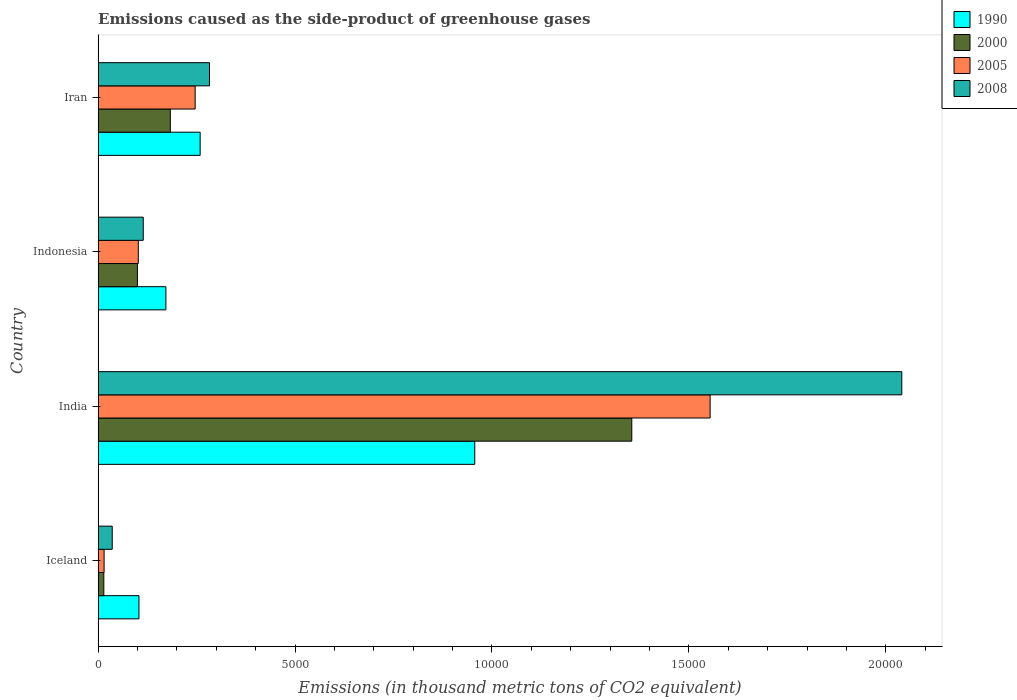How many different coloured bars are there?
Offer a terse response. 4. How many groups of bars are there?
Your answer should be compact. 4. Are the number of bars per tick equal to the number of legend labels?
Ensure brevity in your answer.  Yes. Are the number of bars on each tick of the Y-axis equal?
Provide a short and direct response. Yes. What is the label of the 4th group of bars from the top?
Your response must be concise. Iceland. What is the emissions caused as the side-product of greenhouse gases in 2008 in Iran?
Offer a very short reply. 2828.5. Across all countries, what is the maximum emissions caused as the side-product of greenhouse gases in 2008?
Your answer should be very brief. 2.04e+04. Across all countries, what is the minimum emissions caused as the side-product of greenhouse gases in 2008?
Provide a succinct answer. 358.5. In which country was the emissions caused as the side-product of greenhouse gases in 2005 maximum?
Make the answer very short. India. In which country was the emissions caused as the side-product of greenhouse gases in 2005 minimum?
Ensure brevity in your answer.  Iceland. What is the total emissions caused as the side-product of greenhouse gases in 2008 in the graph?
Give a very brief answer. 2.47e+04. What is the difference between the emissions caused as the side-product of greenhouse gases in 2000 in India and that in Indonesia?
Keep it short and to the point. 1.26e+04. What is the difference between the emissions caused as the side-product of greenhouse gases in 2005 in Iceland and the emissions caused as the side-product of greenhouse gases in 2000 in Iran?
Keep it short and to the point. -1681.7. What is the average emissions caused as the side-product of greenhouse gases in 2005 per country?
Your answer should be very brief. 4793.98. What is the difference between the emissions caused as the side-product of greenhouse gases in 2000 and emissions caused as the side-product of greenhouse gases in 2008 in Iceland?
Offer a terse response. -213.7. What is the ratio of the emissions caused as the side-product of greenhouse gases in 2008 in India to that in Indonesia?
Your answer should be very brief. 17.81. Is the emissions caused as the side-product of greenhouse gases in 2000 in Iceland less than that in India?
Provide a succinct answer. Yes. What is the difference between the highest and the second highest emissions caused as the side-product of greenhouse gases in 2000?
Ensure brevity in your answer.  1.17e+04. What is the difference between the highest and the lowest emissions caused as the side-product of greenhouse gases in 2005?
Make the answer very short. 1.54e+04. Is the sum of the emissions caused as the side-product of greenhouse gases in 1990 in Iceland and Iran greater than the maximum emissions caused as the side-product of greenhouse gases in 2008 across all countries?
Your response must be concise. No. What does the 1st bar from the top in Iran represents?
Offer a very short reply. 2008. What does the 2nd bar from the bottom in Iran represents?
Give a very brief answer. 2000. Are all the bars in the graph horizontal?
Offer a terse response. Yes. How many countries are there in the graph?
Your response must be concise. 4. What is the difference between two consecutive major ticks on the X-axis?
Provide a succinct answer. 5000. Are the values on the major ticks of X-axis written in scientific E-notation?
Give a very brief answer. No. How many legend labels are there?
Provide a short and direct response. 4. What is the title of the graph?
Your response must be concise. Emissions caused as the side-product of greenhouse gases. Does "2006" appear as one of the legend labels in the graph?
Offer a terse response. No. What is the label or title of the X-axis?
Give a very brief answer. Emissions (in thousand metric tons of CO2 equivalent). What is the label or title of the Y-axis?
Ensure brevity in your answer.  Country. What is the Emissions (in thousand metric tons of CO2 equivalent) of 1990 in Iceland?
Ensure brevity in your answer.  1036.9. What is the Emissions (in thousand metric tons of CO2 equivalent) in 2000 in Iceland?
Your answer should be very brief. 144.8. What is the Emissions (in thousand metric tons of CO2 equivalent) of 2005 in Iceland?
Give a very brief answer. 151.7. What is the Emissions (in thousand metric tons of CO2 equivalent) of 2008 in Iceland?
Offer a terse response. 358.5. What is the Emissions (in thousand metric tons of CO2 equivalent) in 1990 in India?
Ensure brevity in your answer.  9563.6. What is the Emissions (in thousand metric tons of CO2 equivalent) of 2000 in India?
Offer a very short reply. 1.36e+04. What is the Emissions (in thousand metric tons of CO2 equivalent) of 2005 in India?
Your answer should be compact. 1.55e+04. What is the Emissions (in thousand metric tons of CO2 equivalent) in 2008 in India?
Provide a succinct answer. 2.04e+04. What is the Emissions (in thousand metric tons of CO2 equivalent) in 1990 in Indonesia?
Ensure brevity in your answer.  1720.7. What is the Emissions (in thousand metric tons of CO2 equivalent) of 2000 in Indonesia?
Ensure brevity in your answer.  997.4. What is the Emissions (in thousand metric tons of CO2 equivalent) in 2005 in Indonesia?
Give a very brief answer. 1020.5. What is the Emissions (in thousand metric tons of CO2 equivalent) in 2008 in Indonesia?
Your answer should be very brief. 1146. What is the Emissions (in thousand metric tons of CO2 equivalent) in 1990 in Iran?
Ensure brevity in your answer.  2590.8. What is the Emissions (in thousand metric tons of CO2 equivalent) of 2000 in Iran?
Provide a succinct answer. 1833.4. What is the Emissions (in thousand metric tons of CO2 equivalent) of 2005 in Iran?
Offer a terse response. 2464. What is the Emissions (in thousand metric tons of CO2 equivalent) of 2008 in Iran?
Offer a terse response. 2828.5. Across all countries, what is the maximum Emissions (in thousand metric tons of CO2 equivalent) of 1990?
Make the answer very short. 9563.6. Across all countries, what is the maximum Emissions (in thousand metric tons of CO2 equivalent) in 2000?
Your response must be concise. 1.36e+04. Across all countries, what is the maximum Emissions (in thousand metric tons of CO2 equivalent) in 2005?
Keep it short and to the point. 1.55e+04. Across all countries, what is the maximum Emissions (in thousand metric tons of CO2 equivalent) in 2008?
Offer a very short reply. 2.04e+04. Across all countries, what is the minimum Emissions (in thousand metric tons of CO2 equivalent) in 1990?
Your answer should be very brief. 1036.9. Across all countries, what is the minimum Emissions (in thousand metric tons of CO2 equivalent) in 2000?
Give a very brief answer. 144.8. Across all countries, what is the minimum Emissions (in thousand metric tons of CO2 equivalent) of 2005?
Your response must be concise. 151.7. Across all countries, what is the minimum Emissions (in thousand metric tons of CO2 equivalent) of 2008?
Offer a terse response. 358.5. What is the total Emissions (in thousand metric tons of CO2 equivalent) of 1990 in the graph?
Your answer should be very brief. 1.49e+04. What is the total Emissions (in thousand metric tons of CO2 equivalent) in 2000 in the graph?
Give a very brief answer. 1.65e+04. What is the total Emissions (in thousand metric tons of CO2 equivalent) in 2005 in the graph?
Give a very brief answer. 1.92e+04. What is the total Emissions (in thousand metric tons of CO2 equivalent) in 2008 in the graph?
Your answer should be very brief. 2.47e+04. What is the difference between the Emissions (in thousand metric tons of CO2 equivalent) of 1990 in Iceland and that in India?
Give a very brief answer. -8526.7. What is the difference between the Emissions (in thousand metric tons of CO2 equivalent) of 2000 in Iceland and that in India?
Your response must be concise. -1.34e+04. What is the difference between the Emissions (in thousand metric tons of CO2 equivalent) of 2005 in Iceland and that in India?
Ensure brevity in your answer.  -1.54e+04. What is the difference between the Emissions (in thousand metric tons of CO2 equivalent) of 2008 in Iceland and that in India?
Provide a succinct answer. -2.00e+04. What is the difference between the Emissions (in thousand metric tons of CO2 equivalent) of 1990 in Iceland and that in Indonesia?
Keep it short and to the point. -683.8. What is the difference between the Emissions (in thousand metric tons of CO2 equivalent) of 2000 in Iceland and that in Indonesia?
Your answer should be compact. -852.6. What is the difference between the Emissions (in thousand metric tons of CO2 equivalent) of 2005 in Iceland and that in Indonesia?
Provide a short and direct response. -868.8. What is the difference between the Emissions (in thousand metric tons of CO2 equivalent) in 2008 in Iceland and that in Indonesia?
Provide a short and direct response. -787.5. What is the difference between the Emissions (in thousand metric tons of CO2 equivalent) in 1990 in Iceland and that in Iran?
Provide a short and direct response. -1553.9. What is the difference between the Emissions (in thousand metric tons of CO2 equivalent) in 2000 in Iceland and that in Iran?
Make the answer very short. -1688.6. What is the difference between the Emissions (in thousand metric tons of CO2 equivalent) of 2005 in Iceland and that in Iran?
Provide a succinct answer. -2312.3. What is the difference between the Emissions (in thousand metric tons of CO2 equivalent) of 2008 in Iceland and that in Iran?
Offer a terse response. -2470. What is the difference between the Emissions (in thousand metric tons of CO2 equivalent) of 1990 in India and that in Indonesia?
Your response must be concise. 7842.9. What is the difference between the Emissions (in thousand metric tons of CO2 equivalent) in 2000 in India and that in Indonesia?
Your answer should be very brief. 1.26e+04. What is the difference between the Emissions (in thousand metric tons of CO2 equivalent) of 2005 in India and that in Indonesia?
Your answer should be very brief. 1.45e+04. What is the difference between the Emissions (in thousand metric tons of CO2 equivalent) in 2008 in India and that in Indonesia?
Your answer should be compact. 1.93e+04. What is the difference between the Emissions (in thousand metric tons of CO2 equivalent) of 1990 in India and that in Iran?
Keep it short and to the point. 6972.8. What is the difference between the Emissions (in thousand metric tons of CO2 equivalent) in 2000 in India and that in Iran?
Your answer should be compact. 1.17e+04. What is the difference between the Emissions (in thousand metric tons of CO2 equivalent) of 2005 in India and that in Iran?
Make the answer very short. 1.31e+04. What is the difference between the Emissions (in thousand metric tons of CO2 equivalent) of 2008 in India and that in Iran?
Your answer should be compact. 1.76e+04. What is the difference between the Emissions (in thousand metric tons of CO2 equivalent) in 1990 in Indonesia and that in Iran?
Provide a short and direct response. -870.1. What is the difference between the Emissions (in thousand metric tons of CO2 equivalent) of 2000 in Indonesia and that in Iran?
Your answer should be compact. -836. What is the difference between the Emissions (in thousand metric tons of CO2 equivalent) of 2005 in Indonesia and that in Iran?
Keep it short and to the point. -1443.5. What is the difference between the Emissions (in thousand metric tons of CO2 equivalent) in 2008 in Indonesia and that in Iran?
Your answer should be very brief. -1682.5. What is the difference between the Emissions (in thousand metric tons of CO2 equivalent) of 1990 in Iceland and the Emissions (in thousand metric tons of CO2 equivalent) of 2000 in India?
Keep it short and to the point. -1.25e+04. What is the difference between the Emissions (in thousand metric tons of CO2 equivalent) in 1990 in Iceland and the Emissions (in thousand metric tons of CO2 equivalent) in 2005 in India?
Your answer should be compact. -1.45e+04. What is the difference between the Emissions (in thousand metric tons of CO2 equivalent) of 1990 in Iceland and the Emissions (in thousand metric tons of CO2 equivalent) of 2008 in India?
Provide a succinct answer. -1.94e+04. What is the difference between the Emissions (in thousand metric tons of CO2 equivalent) in 2000 in Iceland and the Emissions (in thousand metric tons of CO2 equivalent) in 2005 in India?
Offer a terse response. -1.54e+04. What is the difference between the Emissions (in thousand metric tons of CO2 equivalent) in 2000 in Iceland and the Emissions (in thousand metric tons of CO2 equivalent) in 2008 in India?
Your answer should be compact. -2.03e+04. What is the difference between the Emissions (in thousand metric tons of CO2 equivalent) in 2005 in Iceland and the Emissions (in thousand metric tons of CO2 equivalent) in 2008 in India?
Give a very brief answer. -2.03e+04. What is the difference between the Emissions (in thousand metric tons of CO2 equivalent) of 1990 in Iceland and the Emissions (in thousand metric tons of CO2 equivalent) of 2000 in Indonesia?
Keep it short and to the point. 39.5. What is the difference between the Emissions (in thousand metric tons of CO2 equivalent) in 1990 in Iceland and the Emissions (in thousand metric tons of CO2 equivalent) in 2008 in Indonesia?
Provide a short and direct response. -109.1. What is the difference between the Emissions (in thousand metric tons of CO2 equivalent) in 2000 in Iceland and the Emissions (in thousand metric tons of CO2 equivalent) in 2005 in Indonesia?
Offer a very short reply. -875.7. What is the difference between the Emissions (in thousand metric tons of CO2 equivalent) of 2000 in Iceland and the Emissions (in thousand metric tons of CO2 equivalent) of 2008 in Indonesia?
Give a very brief answer. -1001.2. What is the difference between the Emissions (in thousand metric tons of CO2 equivalent) of 2005 in Iceland and the Emissions (in thousand metric tons of CO2 equivalent) of 2008 in Indonesia?
Ensure brevity in your answer.  -994.3. What is the difference between the Emissions (in thousand metric tons of CO2 equivalent) of 1990 in Iceland and the Emissions (in thousand metric tons of CO2 equivalent) of 2000 in Iran?
Give a very brief answer. -796.5. What is the difference between the Emissions (in thousand metric tons of CO2 equivalent) in 1990 in Iceland and the Emissions (in thousand metric tons of CO2 equivalent) in 2005 in Iran?
Provide a short and direct response. -1427.1. What is the difference between the Emissions (in thousand metric tons of CO2 equivalent) of 1990 in Iceland and the Emissions (in thousand metric tons of CO2 equivalent) of 2008 in Iran?
Provide a short and direct response. -1791.6. What is the difference between the Emissions (in thousand metric tons of CO2 equivalent) in 2000 in Iceland and the Emissions (in thousand metric tons of CO2 equivalent) in 2005 in Iran?
Provide a short and direct response. -2319.2. What is the difference between the Emissions (in thousand metric tons of CO2 equivalent) of 2000 in Iceland and the Emissions (in thousand metric tons of CO2 equivalent) of 2008 in Iran?
Give a very brief answer. -2683.7. What is the difference between the Emissions (in thousand metric tons of CO2 equivalent) in 2005 in Iceland and the Emissions (in thousand metric tons of CO2 equivalent) in 2008 in Iran?
Provide a succinct answer. -2676.8. What is the difference between the Emissions (in thousand metric tons of CO2 equivalent) in 1990 in India and the Emissions (in thousand metric tons of CO2 equivalent) in 2000 in Indonesia?
Your answer should be compact. 8566.2. What is the difference between the Emissions (in thousand metric tons of CO2 equivalent) of 1990 in India and the Emissions (in thousand metric tons of CO2 equivalent) of 2005 in Indonesia?
Offer a terse response. 8543.1. What is the difference between the Emissions (in thousand metric tons of CO2 equivalent) in 1990 in India and the Emissions (in thousand metric tons of CO2 equivalent) in 2008 in Indonesia?
Your answer should be compact. 8417.6. What is the difference between the Emissions (in thousand metric tons of CO2 equivalent) of 2000 in India and the Emissions (in thousand metric tons of CO2 equivalent) of 2005 in Indonesia?
Provide a succinct answer. 1.25e+04. What is the difference between the Emissions (in thousand metric tons of CO2 equivalent) of 2000 in India and the Emissions (in thousand metric tons of CO2 equivalent) of 2008 in Indonesia?
Offer a very short reply. 1.24e+04. What is the difference between the Emissions (in thousand metric tons of CO2 equivalent) of 2005 in India and the Emissions (in thousand metric tons of CO2 equivalent) of 2008 in Indonesia?
Ensure brevity in your answer.  1.44e+04. What is the difference between the Emissions (in thousand metric tons of CO2 equivalent) of 1990 in India and the Emissions (in thousand metric tons of CO2 equivalent) of 2000 in Iran?
Ensure brevity in your answer.  7730.2. What is the difference between the Emissions (in thousand metric tons of CO2 equivalent) of 1990 in India and the Emissions (in thousand metric tons of CO2 equivalent) of 2005 in Iran?
Give a very brief answer. 7099.6. What is the difference between the Emissions (in thousand metric tons of CO2 equivalent) of 1990 in India and the Emissions (in thousand metric tons of CO2 equivalent) of 2008 in Iran?
Keep it short and to the point. 6735.1. What is the difference between the Emissions (in thousand metric tons of CO2 equivalent) of 2000 in India and the Emissions (in thousand metric tons of CO2 equivalent) of 2005 in Iran?
Keep it short and to the point. 1.11e+04. What is the difference between the Emissions (in thousand metric tons of CO2 equivalent) in 2000 in India and the Emissions (in thousand metric tons of CO2 equivalent) in 2008 in Iran?
Provide a short and direct response. 1.07e+04. What is the difference between the Emissions (in thousand metric tons of CO2 equivalent) of 2005 in India and the Emissions (in thousand metric tons of CO2 equivalent) of 2008 in Iran?
Offer a very short reply. 1.27e+04. What is the difference between the Emissions (in thousand metric tons of CO2 equivalent) of 1990 in Indonesia and the Emissions (in thousand metric tons of CO2 equivalent) of 2000 in Iran?
Provide a succinct answer. -112.7. What is the difference between the Emissions (in thousand metric tons of CO2 equivalent) in 1990 in Indonesia and the Emissions (in thousand metric tons of CO2 equivalent) in 2005 in Iran?
Your response must be concise. -743.3. What is the difference between the Emissions (in thousand metric tons of CO2 equivalent) of 1990 in Indonesia and the Emissions (in thousand metric tons of CO2 equivalent) of 2008 in Iran?
Provide a short and direct response. -1107.8. What is the difference between the Emissions (in thousand metric tons of CO2 equivalent) of 2000 in Indonesia and the Emissions (in thousand metric tons of CO2 equivalent) of 2005 in Iran?
Give a very brief answer. -1466.6. What is the difference between the Emissions (in thousand metric tons of CO2 equivalent) in 2000 in Indonesia and the Emissions (in thousand metric tons of CO2 equivalent) in 2008 in Iran?
Your answer should be very brief. -1831.1. What is the difference between the Emissions (in thousand metric tons of CO2 equivalent) in 2005 in Indonesia and the Emissions (in thousand metric tons of CO2 equivalent) in 2008 in Iran?
Make the answer very short. -1808. What is the average Emissions (in thousand metric tons of CO2 equivalent) in 1990 per country?
Provide a short and direct response. 3728. What is the average Emissions (in thousand metric tons of CO2 equivalent) of 2000 per country?
Provide a succinct answer. 4131.57. What is the average Emissions (in thousand metric tons of CO2 equivalent) in 2005 per country?
Keep it short and to the point. 4793.98. What is the average Emissions (in thousand metric tons of CO2 equivalent) of 2008 per country?
Provide a short and direct response. 6184.98. What is the difference between the Emissions (in thousand metric tons of CO2 equivalent) of 1990 and Emissions (in thousand metric tons of CO2 equivalent) of 2000 in Iceland?
Ensure brevity in your answer.  892.1. What is the difference between the Emissions (in thousand metric tons of CO2 equivalent) in 1990 and Emissions (in thousand metric tons of CO2 equivalent) in 2005 in Iceland?
Offer a terse response. 885.2. What is the difference between the Emissions (in thousand metric tons of CO2 equivalent) of 1990 and Emissions (in thousand metric tons of CO2 equivalent) of 2008 in Iceland?
Give a very brief answer. 678.4. What is the difference between the Emissions (in thousand metric tons of CO2 equivalent) in 2000 and Emissions (in thousand metric tons of CO2 equivalent) in 2005 in Iceland?
Keep it short and to the point. -6.9. What is the difference between the Emissions (in thousand metric tons of CO2 equivalent) in 2000 and Emissions (in thousand metric tons of CO2 equivalent) in 2008 in Iceland?
Provide a short and direct response. -213.7. What is the difference between the Emissions (in thousand metric tons of CO2 equivalent) of 2005 and Emissions (in thousand metric tons of CO2 equivalent) of 2008 in Iceland?
Your answer should be very brief. -206.8. What is the difference between the Emissions (in thousand metric tons of CO2 equivalent) in 1990 and Emissions (in thousand metric tons of CO2 equivalent) in 2000 in India?
Your answer should be compact. -3987.1. What is the difference between the Emissions (in thousand metric tons of CO2 equivalent) in 1990 and Emissions (in thousand metric tons of CO2 equivalent) in 2005 in India?
Offer a terse response. -5976.1. What is the difference between the Emissions (in thousand metric tons of CO2 equivalent) of 1990 and Emissions (in thousand metric tons of CO2 equivalent) of 2008 in India?
Give a very brief answer. -1.08e+04. What is the difference between the Emissions (in thousand metric tons of CO2 equivalent) in 2000 and Emissions (in thousand metric tons of CO2 equivalent) in 2005 in India?
Your response must be concise. -1989. What is the difference between the Emissions (in thousand metric tons of CO2 equivalent) of 2000 and Emissions (in thousand metric tons of CO2 equivalent) of 2008 in India?
Your response must be concise. -6856.2. What is the difference between the Emissions (in thousand metric tons of CO2 equivalent) of 2005 and Emissions (in thousand metric tons of CO2 equivalent) of 2008 in India?
Offer a very short reply. -4867.2. What is the difference between the Emissions (in thousand metric tons of CO2 equivalent) in 1990 and Emissions (in thousand metric tons of CO2 equivalent) in 2000 in Indonesia?
Provide a succinct answer. 723.3. What is the difference between the Emissions (in thousand metric tons of CO2 equivalent) of 1990 and Emissions (in thousand metric tons of CO2 equivalent) of 2005 in Indonesia?
Make the answer very short. 700.2. What is the difference between the Emissions (in thousand metric tons of CO2 equivalent) of 1990 and Emissions (in thousand metric tons of CO2 equivalent) of 2008 in Indonesia?
Give a very brief answer. 574.7. What is the difference between the Emissions (in thousand metric tons of CO2 equivalent) in 2000 and Emissions (in thousand metric tons of CO2 equivalent) in 2005 in Indonesia?
Offer a very short reply. -23.1. What is the difference between the Emissions (in thousand metric tons of CO2 equivalent) of 2000 and Emissions (in thousand metric tons of CO2 equivalent) of 2008 in Indonesia?
Give a very brief answer. -148.6. What is the difference between the Emissions (in thousand metric tons of CO2 equivalent) in 2005 and Emissions (in thousand metric tons of CO2 equivalent) in 2008 in Indonesia?
Offer a very short reply. -125.5. What is the difference between the Emissions (in thousand metric tons of CO2 equivalent) in 1990 and Emissions (in thousand metric tons of CO2 equivalent) in 2000 in Iran?
Your response must be concise. 757.4. What is the difference between the Emissions (in thousand metric tons of CO2 equivalent) in 1990 and Emissions (in thousand metric tons of CO2 equivalent) in 2005 in Iran?
Make the answer very short. 126.8. What is the difference between the Emissions (in thousand metric tons of CO2 equivalent) of 1990 and Emissions (in thousand metric tons of CO2 equivalent) of 2008 in Iran?
Ensure brevity in your answer.  -237.7. What is the difference between the Emissions (in thousand metric tons of CO2 equivalent) in 2000 and Emissions (in thousand metric tons of CO2 equivalent) in 2005 in Iran?
Your answer should be compact. -630.6. What is the difference between the Emissions (in thousand metric tons of CO2 equivalent) in 2000 and Emissions (in thousand metric tons of CO2 equivalent) in 2008 in Iran?
Keep it short and to the point. -995.1. What is the difference between the Emissions (in thousand metric tons of CO2 equivalent) in 2005 and Emissions (in thousand metric tons of CO2 equivalent) in 2008 in Iran?
Provide a succinct answer. -364.5. What is the ratio of the Emissions (in thousand metric tons of CO2 equivalent) of 1990 in Iceland to that in India?
Keep it short and to the point. 0.11. What is the ratio of the Emissions (in thousand metric tons of CO2 equivalent) of 2000 in Iceland to that in India?
Offer a very short reply. 0.01. What is the ratio of the Emissions (in thousand metric tons of CO2 equivalent) in 2005 in Iceland to that in India?
Provide a short and direct response. 0.01. What is the ratio of the Emissions (in thousand metric tons of CO2 equivalent) in 2008 in Iceland to that in India?
Provide a succinct answer. 0.02. What is the ratio of the Emissions (in thousand metric tons of CO2 equivalent) in 1990 in Iceland to that in Indonesia?
Give a very brief answer. 0.6. What is the ratio of the Emissions (in thousand metric tons of CO2 equivalent) of 2000 in Iceland to that in Indonesia?
Offer a very short reply. 0.15. What is the ratio of the Emissions (in thousand metric tons of CO2 equivalent) of 2005 in Iceland to that in Indonesia?
Give a very brief answer. 0.15. What is the ratio of the Emissions (in thousand metric tons of CO2 equivalent) of 2008 in Iceland to that in Indonesia?
Offer a very short reply. 0.31. What is the ratio of the Emissions (in thousand metric tons of CO2 equivalent) of 1990 in Iceland to that in Iran?
Offer a terse response. 0.4. What is the ratio of the Emissions (in thousand metric tons of CO2 equivalent) of 2000 in Iceland to that in Iran?
Give a very brief answer. 0.08. What is the ratio of the Emissions (in thousand metric tons of CO2 equivalent) of 2005 in Iceland to that in Iran?
Offer a terse response. 0.06. What is the ratio of the Emissions (in thousand metric tons of CO2 equivalent) in 2008 in Iceland to that in Iran?
Your answer should be very brief. 0.13. What is the ratio of the Emissions (in thousand metric tons of CO2 equivalent) in 1990 in India to that in Indonesia?
Your answer should be very brief. 5.56. What is the ratio of the Emissions (in thousand metric tons of CO2 equivalent) in 2000 in India to that in Indonesia?
Your answer should be very brief. 13.59. What is the ratio of the Emissions (in thousand metric tons of CO2 equivalent) of 2005 in India to that in Indonesia?
Keep it short and to the point. 15.23. What is the ratio of the Emissions (in thousand metric tons of CO2 equivalent) in 2008 in India to that in Indonesia?
Your response must be concise. 17.81. What is the ratio of the Emissions (in thousand metric tons of CO2 equivalent) of 1990 in India to that in Iran?
Provide a short and direct response. 3.69. What is the ratio of the Emissions (in thousand metric tons of CO2 equivalent) of 2000 in India to that in Iran?
Your response must be concise. 7.39. What is the ratio of the Emissions (in thousand metric tons of CO2 equivalent) of 2005 in India to that in Iran?
Give a very brief answer. 6.31. What is the ratio of the Emissions (in thousand metric tons of CO2 equivalent) of 2008 in India to that in Iran?
Your answer should be very brief. 7.21. What is the ratio of the Emissions (in thousand metric tons of CO2 equivalent) in 1990 in Indonesia to that in Iran?
Make the answer very short. 0.66. What is the ratio of the Emissions (in thousand metric tons of CO2 equivalent) of 2000 in Indonesia to that in Iran?
Give a very brief answer. 0.54. What is the ratio of the Emissions (in thousand metric tons of CO2 equivalent) in 2005 in Indonesia to that in Iran?
Offer a terse response. 0.41. What is the ratio of the Emissions (in thousand metric tons of CO2 equivalent) of 2008 in Indonesia to that in Iran?
Keep it short and to the point. 0.41. What is the difference between the highest and the second highest Emissions (in thousand metric tons of CO2 equivalent) in 1990?
Your answer should be very brief. 6972.8. What is the difference between the highest and the second highest Emissions (in thousand metric tons of CO2 equivalent) in 2000?
Offer a very short reply. 1.17e+04. What is the difference between the highest and the second highest Emissions (in thousand metric tons of CO2 equivalent) of 2005?
Ensure brevity in your answer.  1.31e+04. What is the difference between the highest and the second highest Emissions (in thousand metric tons of CO2 equivalent) in 2008?
Your answer should be compact. 1.76e+04. What is the difference between the highest and the lowest Emissions (in thousand metric tons of CO2 equivalent) in 1990?
Offer a terse response. 8526.7. What is the difference between the highest and the lowest Emissions (in thousand metric tons of CO2 equivalent) of 2000?
Provide a short and direct response. 1.34e+04. What is the difference between the highest and the lowest Emissions (in thousand metric tons of CO2 equivalent) in 2005?
Keep it short and to the point. 1.54e+04. What is the difference between the highest and the lowest Emissions (in thousand metric tons of CO2 equivalent) in 2008?
Offer a very short reply. 2.00e+04. 